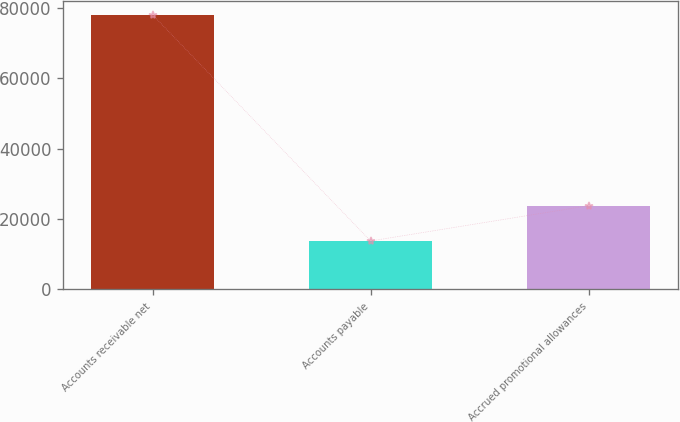Convert chart. <chart><loc_0><loc_0><loc_500><loc_500><bar_chart><fcel>Accounts receivable net<fcel>Accounts payable<fcel>Accrued promotional allowances<nl><fcel>78011<fcel>13738<fcel>23776<nl></chart> 